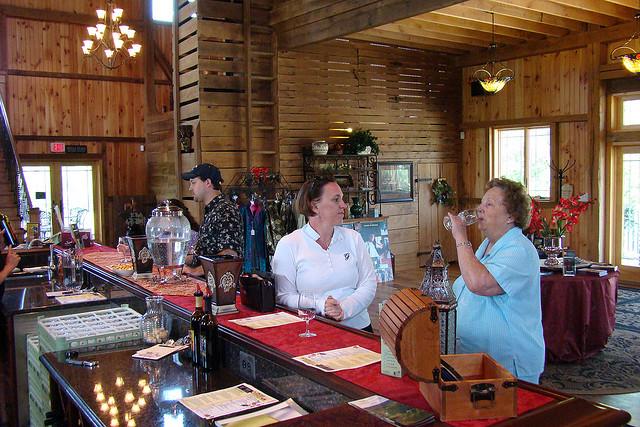Is this a saloon or restaurant?
Quick response, please. Saloon. What do you think the woman is drinking?
Quick response, please. Wine. Is the chest closed?
Keep it brief. No. Does it seem that some people are colder than others here?
Give a very brief answer. No. 